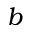<formula> <loc_0><loc_0><loc_500><loc_500>b</formula> 